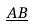<formula> <loc_0><loc_0><loc_500><loc_500>\underline { A B }</formula> 